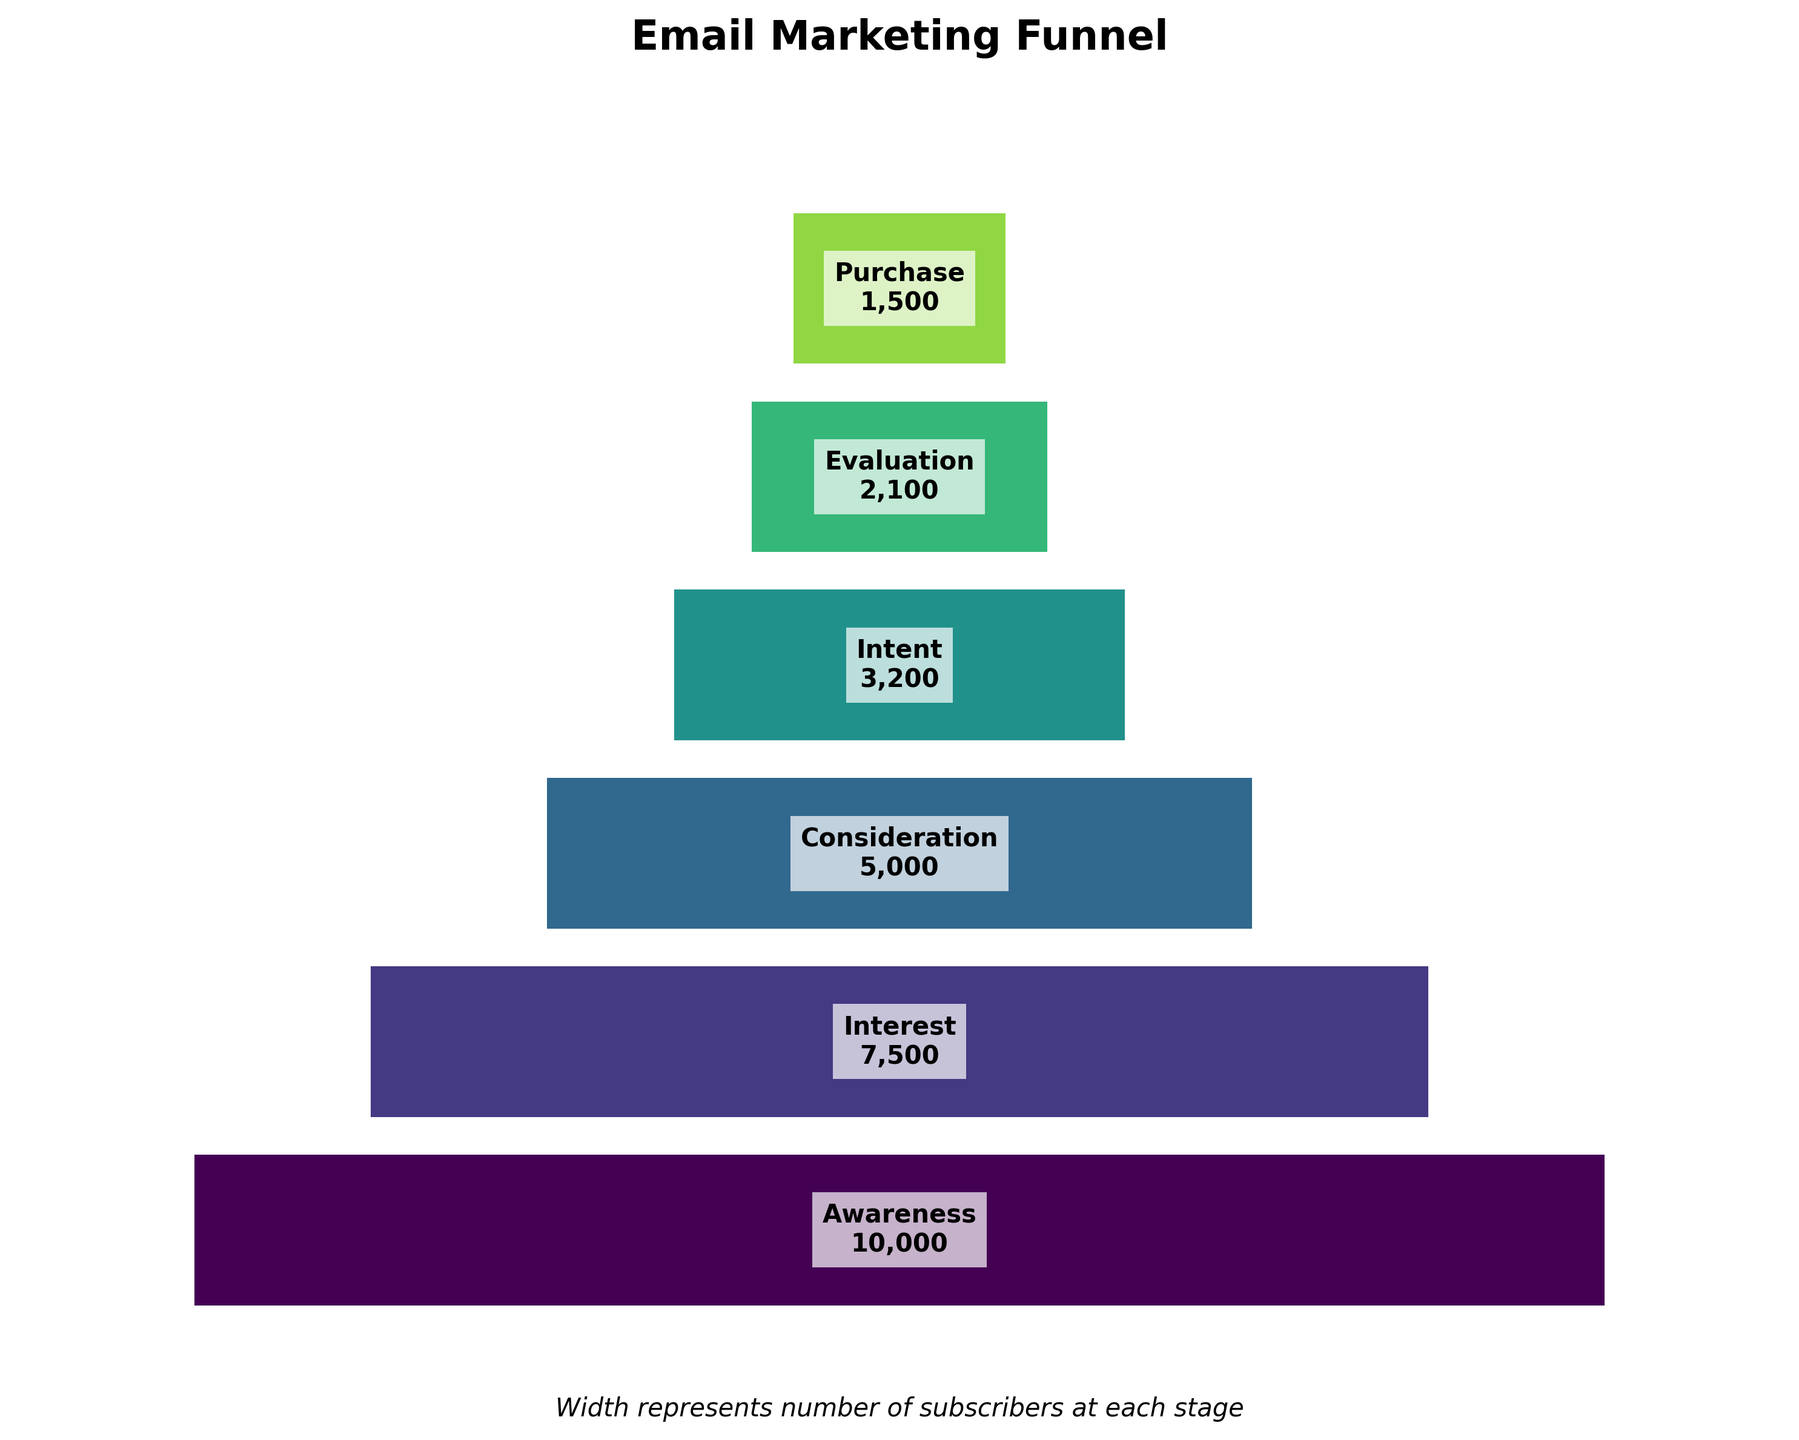What is the title of the chart? The title is usually found at the top of the chart and describes the main subject of the visualization. In this case, it's easily identifiable.
Answer: Email Marketing Funnel How many stages are there in the funnel? Counting the number of funnel segments gives us the total number of stages. There are six labels: Awareness, Interest, Consideration, Intent, Evaluation, and Purchase.
Answer: 6 Which stage has the highest number of subscribers? The width of each stage in the funnel represents the number of subscribers. The widest segment corresponds to the highest number of subscribers. Here, the Awareness stage is the widest.
Answer: Awareness What is the difference in the number of subscribers between the Awareness and Interest stages? Subtract the number of subscribers in the Interest stage (7,500) from those in the Awareness stage (10,000) to find the difference. 10,000 - 7,500 = 2,500.
Answer: 2,500 Are there more subscribers in the Consideration stage or the Intent stage? Comparing the widths of the Consideration and Intent stages, the Consideration stage is wider. Therefore, it has more subscribers.
Answer: Consideration What percent of the subscribers in the Awareness stage moved on to the Consideration stage? To calculate the percentage, divide the number of subscribers in the Consideration stage (5,000) by the number of subscribers in the Awareness stage (10,000) and multiply by 100. (5,000 / 10,000) * 100 = 50%.
Answer: 50% Is the subscription drop from Intent to Evaluation higher or lower than from Consideration to Intent? Calculate the differences: from Intent (3,200) to Evaluation (2,100) is 3,200 - 2,100 = 1,100, and from Consideration (5,000) to Intent (3,200) is 5,000 - 3,200 = 1,800. Then, compare these values. 1,100 < 1,800, so the drop from Intent to Evaluation is lower.
Answer: Lower What is the average number of subscribers across all stages? First, sum the subscribers in all stages (10,000 + 7,500 + 5,000 + 3,200 + 2,100 + 1,500 = 29,300). Then, divide by the number of stages (29,300 / 6 ≈ 4,883).
Answer: approximately 4,883 If each stage were represented as a percentage of total subscribers at the Awareness stage, what would be the percentage for the Purchase stage? Divide the number of subscribers in the Purchase stage (1,500) by the number of subscribers in the Awareness stage (10,000), then multiply by 100 to convert to a percentage. (1,500 / 10,000) * 100 = 15%.
Answer: 15% 